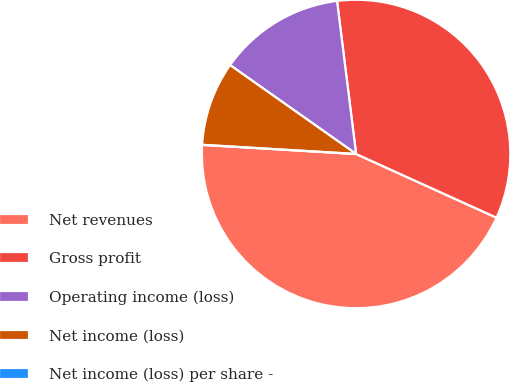Convert chart. <chart><loc_0><loc_0><loc_500><loc_500><pie_chart><fcel>Net revenues<fcel>Gross profit<fcel>Operating income (loss)<fcel>Net income (loss)<fcel>Net income (loss) per share -<nl><fcel>44.17%<fcel>33.75%<fcel>13.25%<fcel>8.83%<fcel>0.0%<nl></chart> 